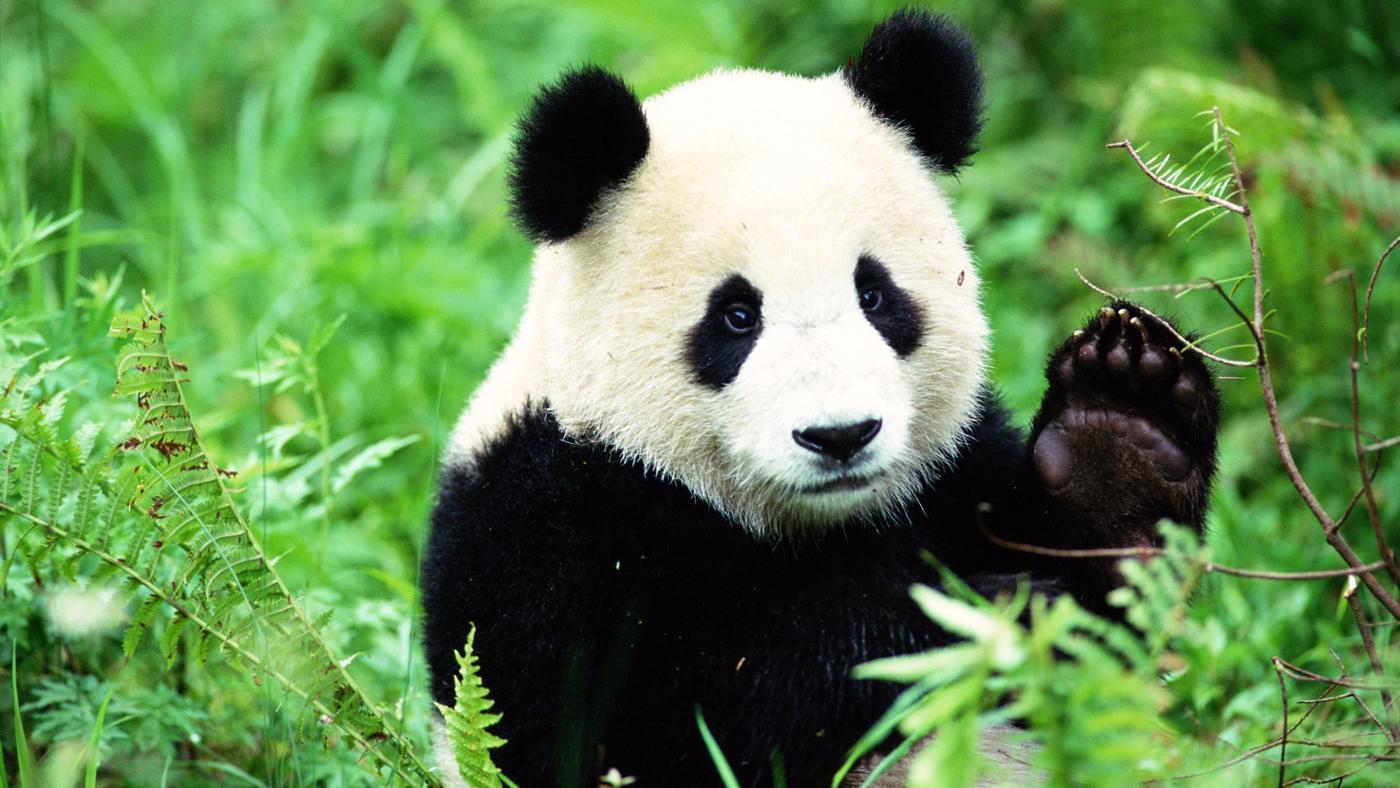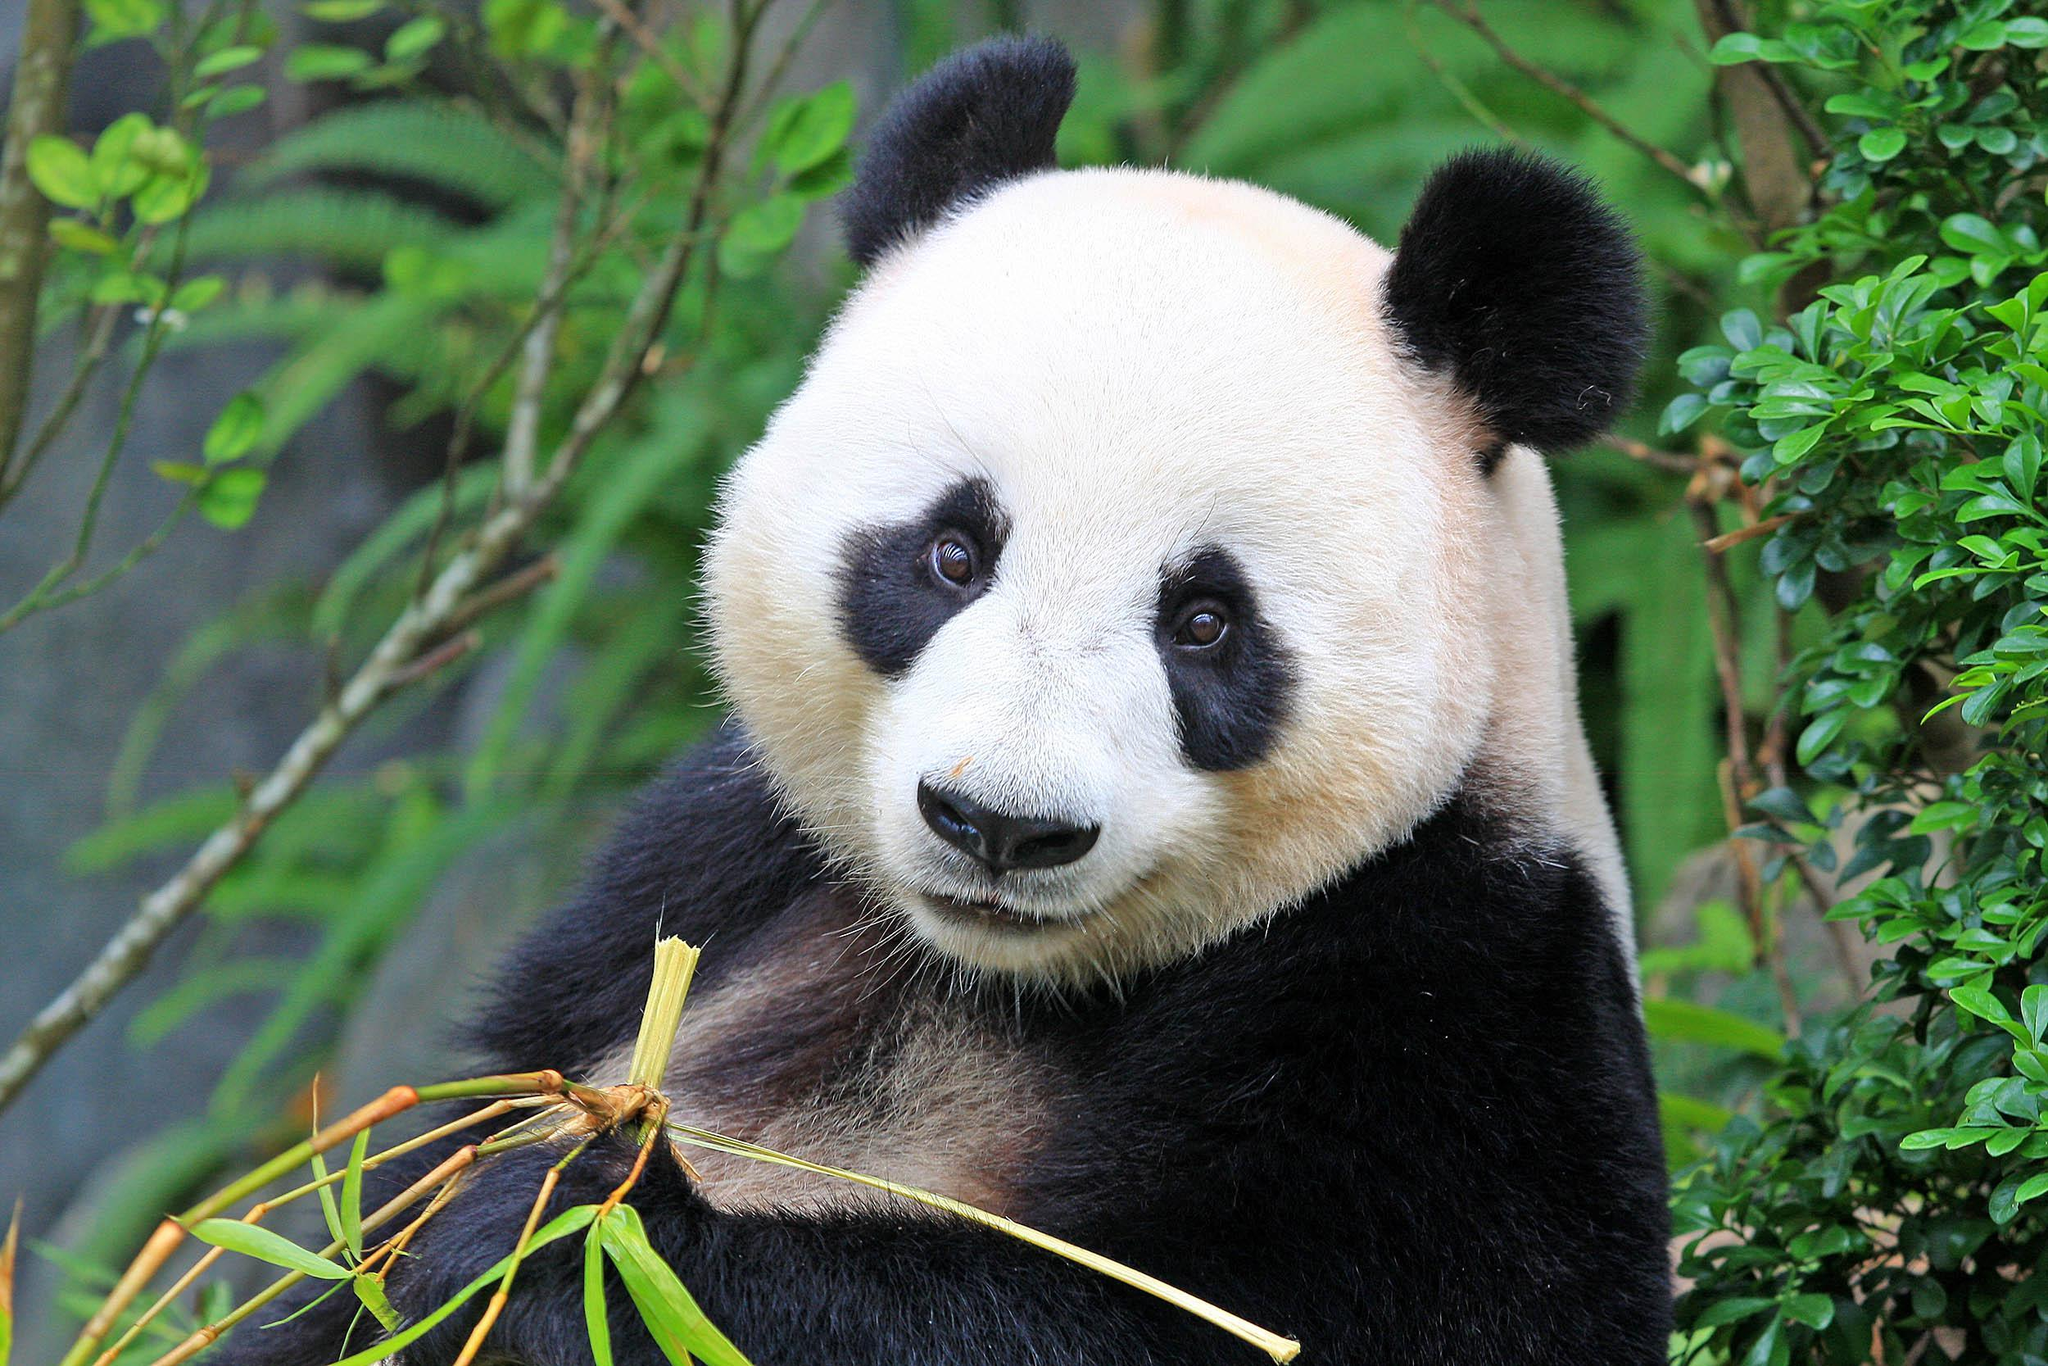The first image is the image on the left, the second image is the image on the right. Assess this claim about the two images: "An image shows a brown and white panda surrounded by foliage.". Correct or not? Answer yes or no. No. The first image is the image on the left, the second image is the image on the right. Assess this claim about the two images: "The left image contains a panda chewing on food.". Correct or not? Answer yes or no. No. 